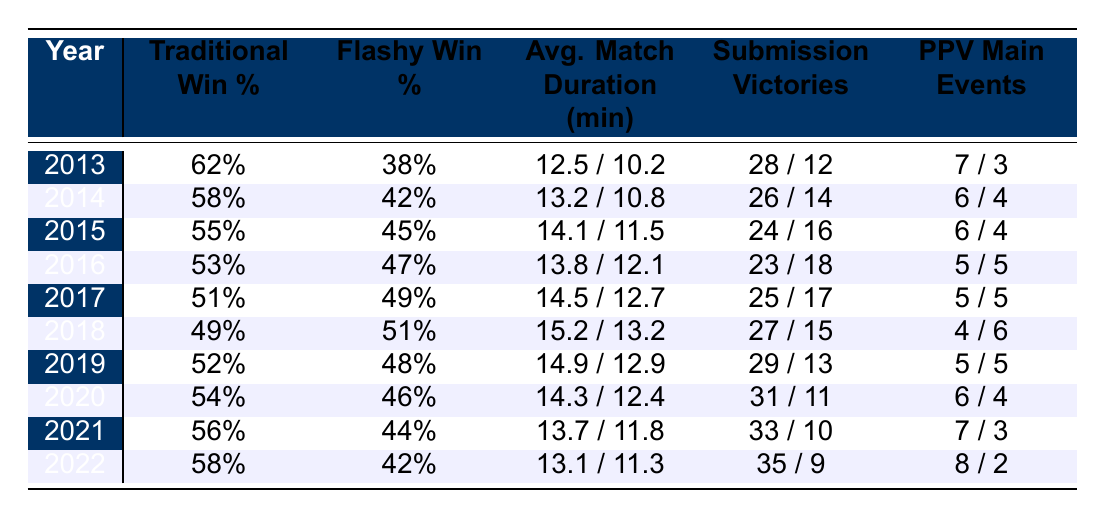What was the traditional win percentage in 2015? The table shows the traditional win percentage for the year 2015 as 55%.
Answer: 55% Which year had the highest flashy win percentage? By examining the table, the flashy win percentage peaks at 51% in 2018.
Answer: 51% What is the average match duration for traditional wrestling in 2020? The table lists the average match duration for traditional wrestling in 2020 as 14.3 minutes.
Answer: 14.3 minutes How many submission victories did flashy wrestlers have in 2022? In 2022, flashy wrestlers secured 9 submission victories, as indicated in the table.
Answer: 9 Did traditional wrestling have more PPV main events than flashy wrestling in 2017? The table shows that traditional wrestling had 5 PPV main events while flashy wrestling also had 5, therefore they tied.
Answer: Yes, they tied What is the difference in traditional win percentage between 2013 and 2022? The traditional win percentage in 2013 was 62% and in 2022 it was 58%, so the difference is 62% - 58% = 4%.
Answer: 4% What was the average match duration for flashy wrestling over the last decade? To find the average, add flashy match durations (10.2 + 10.8 + 11.5 + 12.1 + 12.7 + 13.2 + 12.9 + 12.4 + 11.8 + 11.3 = 128.0), then divide by 10, resulting in an average of 12.8 minutes.
Answer: 12.8 minutes Which wrestler was often recognized as the top traditional wrestler from the data provided? The table indicates that the top traditional wrestler in 2022 was Roman Reigns.
Answer: Roman Reigns How many total submission victories were there for traditional wrestlers from 2013 to 2022? By summing the submission victories from the table (28 + 26 + 24 + 23 + 25 + 27 + 29 + 31 + 33 + 35 =  257), there were a total of 257 traditional submission victories.
Answer: 257 Which style had a higher number of PPV main events in 2018? From the table, traditional wrestling had 4 PPV main events, while flashy wrestling had 6, therefore flashy wrestling had more.
Answer: Flashy wrestling had more 